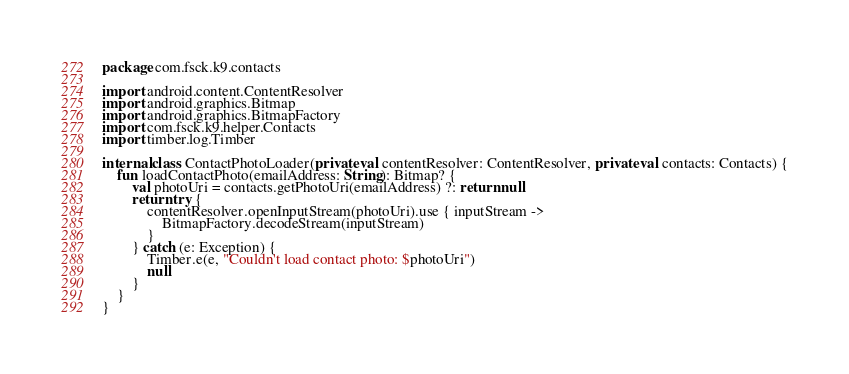<code> <loc_0><loc_0><loc_500><loc_500><_Kotlin_>package com.fsck.k9.contacts

import android.content.ContentResolver
import android.graphics.Bitmap
import android.graphics.BitmapFactory
import com.fsck.k9.helper.Contacts
import timber.log.Timber

internal class ContactPhotoLoader(private val contentResolver: ContentResolver, private val contacts: Contacts) {
    fun loadContactPhoto(emailAddress: String): Bitmap? {
        val photoUri = contacts.getPhotoUri(emailAddress) ?: return null
        return try {
            contentResolver.openInputStream(photoUri).use { inputStream ->
                BitmapFactory.decodeStream(inputStream)
            }
        } catch (e: Exception) {
            Timber.e(e, "Couldn't load contact photo: $photoUri")
            null
        }
    }
}
</code> 